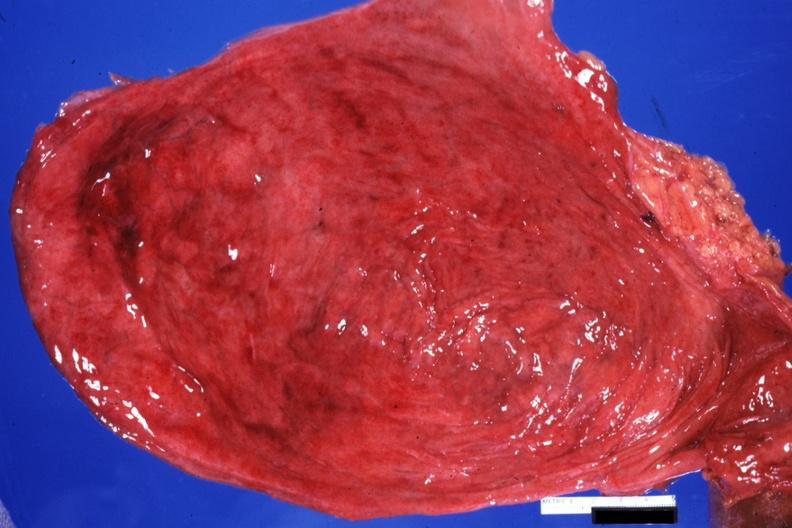s urinary present?
Answer the question using a single word or phrase. Yes 